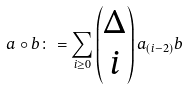Convert formula to latex. <formula><loc_0><loc_0><loc_500><loc_500>a \circ b \colon = \sum _ { i \geq 0 } \begin{pmatrix} \Delta \\ i \end{pmatrix} a _ { ( i - 2 ) } b</formula> 